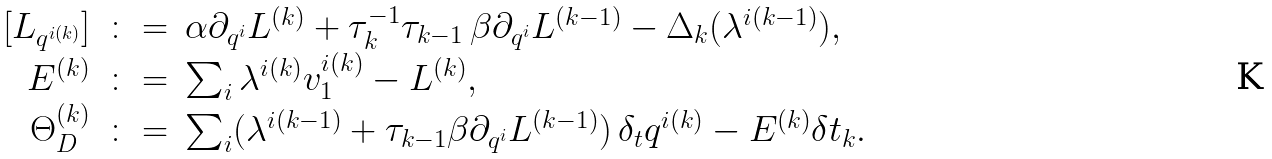Convert formula to latex. <formula><loc_0><loc_0><loc_500><loc_500>\begin{array} { r c l } [ L _ { q ^ { i ( k ) } } ] & \colon = & \alpha \partial _ { q ^ { i } } L ^ { ( k ) } + \tau _ { k } ^ { - 1 } \tau _ { k - 1 } \, \beta \partial _ { q ^ { i } } L ^ { ( k - 1 ) } - \Delta _ { k } ( \lambda ^ { i ( k - 1 ) } ) , \\ E ^ { ( k ) } & \colon = & \sum _ { i } \lambda ^ { i ( k ) } v _ { 1 } ^ { i ( k ) } - L ^ { ( k ) } , \\ \Theta _ { D } ^ { ( k ) } & \colon = & \sum _ { i } ( \lambda ^ { i ( k - 1 ) } + \tau _ { k - 1 } \beta \partial _ { q ^ { i } } L ^ { ( k - 1 ) } ) \, \delta _ { t } q ^ { i ( k ) } - E ^ { ( k ) } \delta t _ { k } . \end{array}</formula> 